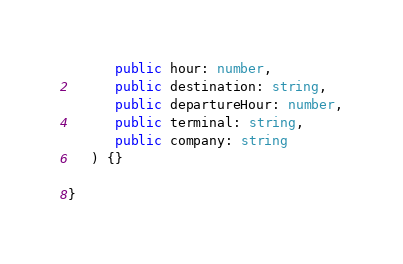<code> <loc_0><loc_0><loc_500><loc_500><_TypeScript_>      public hour: number,
      public destination: string,
      public departureHour: number,
      public terminal: string,
      public company: string
   ) {}

}
</code> 